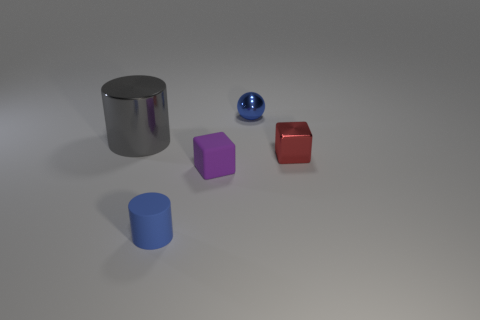Is there anything else that has the same shape as the small blue metallic thing?
Offer a very short reply. No. Is there any other thing that has the same size as the gray metal object?
Offer a terse response. No. How many small rubber objects have the same shape as the red shiny object?
Your answer should be compact. 1. There is a gray cylinder that is made of the same material as the red object; what size is it?
Your response must be concise. Large. There is a small thing that is behind the big metal cylinder that is left of the purple block; what is its color?
Provide a succinct answer. Blue. Does the blue rubber object have the same shape as the gray shiny object that is left of the red cube?
Make the answer very short. Yes. What number of purple rubber cubes are the same size as the purple object?
Offer a terse response. 0. There is another object that is the same shape as the small red thing; what material is it?
Your answer should be very brief. Rubber. Is the color of the small thing in front of the small purple matte thing the same as the tiny metal thing that is behind the metal cube?
Provide a short and direct response. Yes. What shape is the blue object that is in front of the big gray thing?
Give a very brief answer. Cylinder. 